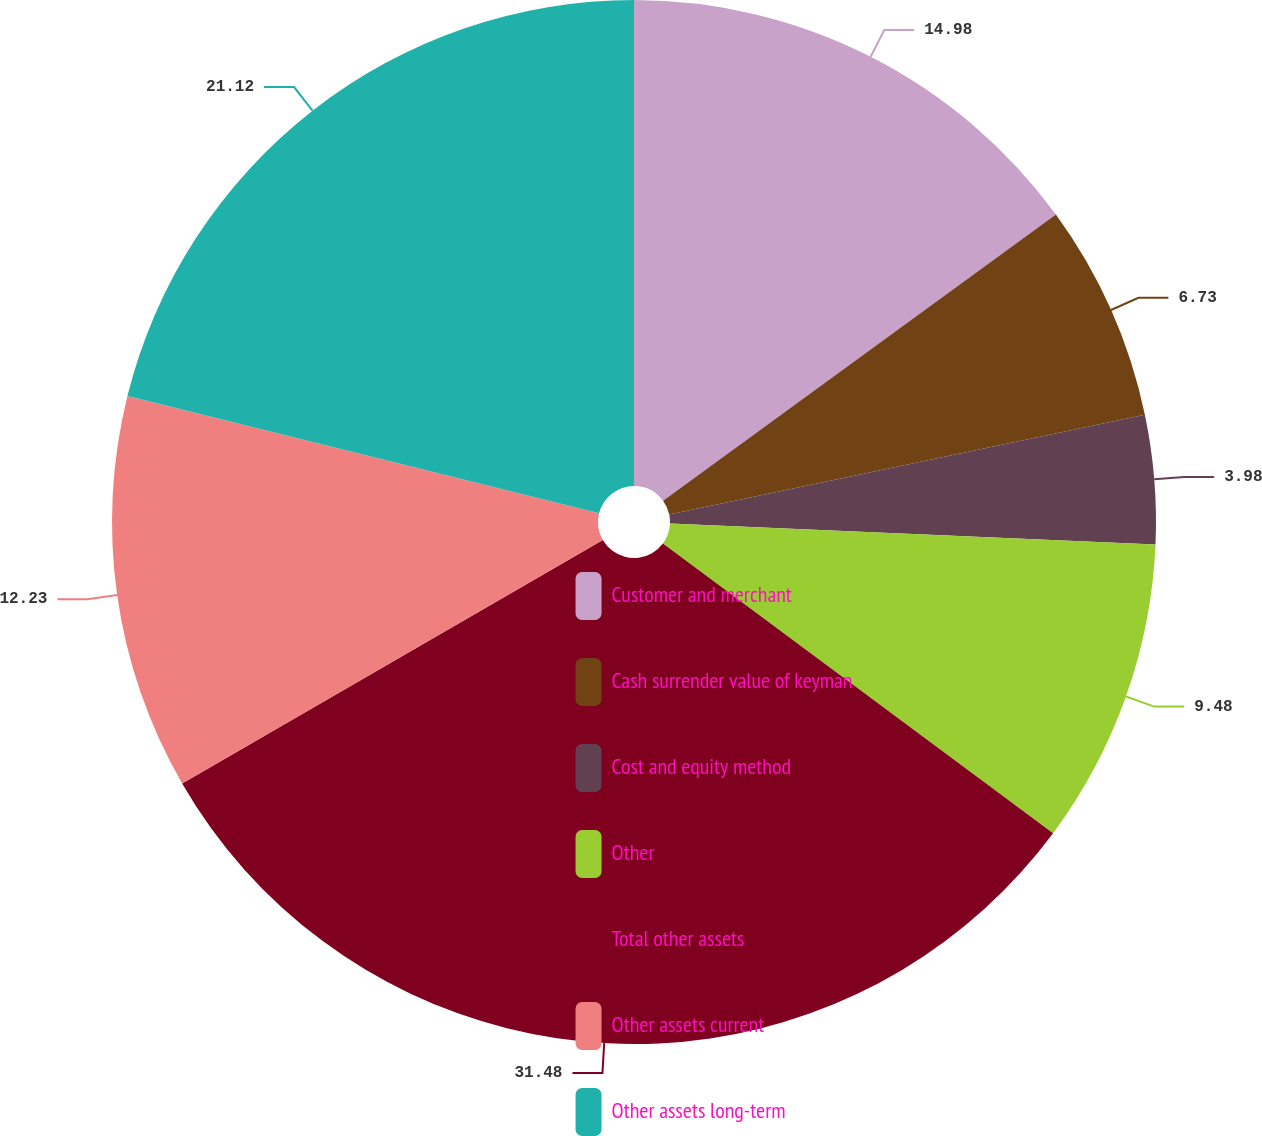Convert chart to OTSL. <chart><loc_0><loc_0><loc_500><loc_500><pie_chart><fcel>Customer and merchant<fcel>Cash surrender value of keyman<fcel>Cost and equity method<fcel>Other<fcel>Total other assets<fcel>Other assets current<fcel>Other assets long-term<nl><fcel>14.98%<fcel>6.73%<fcel>3.98%<fcel>9.48%<fcel>31.49%<fcel>12.23%<fcel>21.12%<nl></chart> 